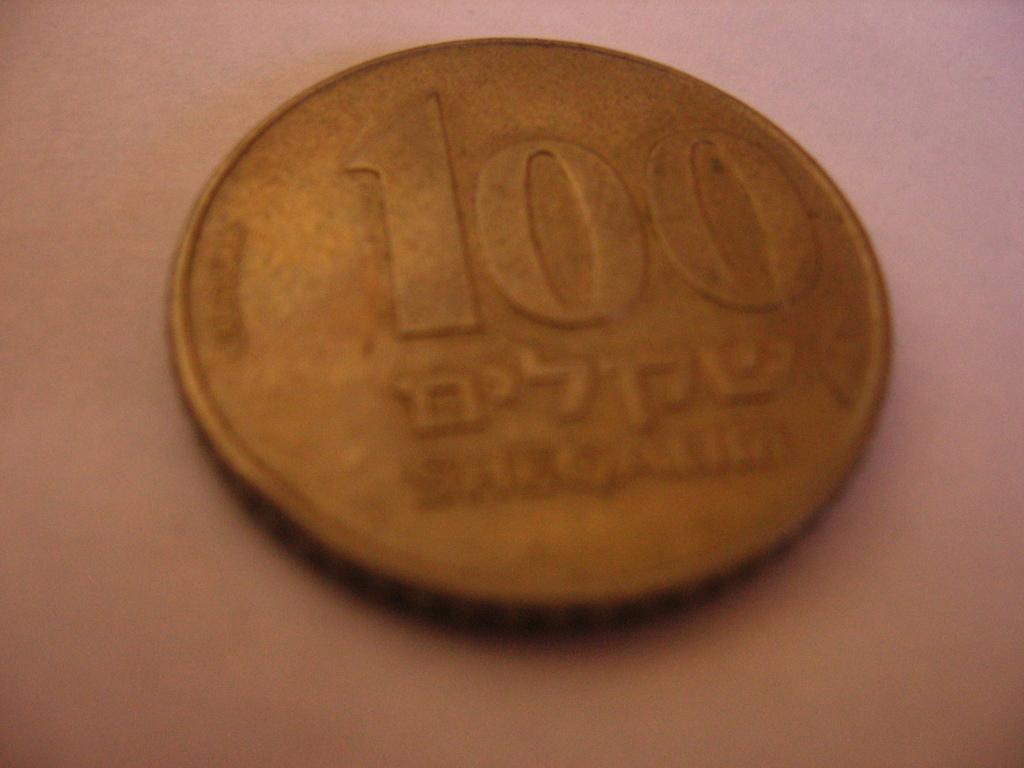In one or two sentences, can you explain what this image depicts? In this picture I can see the light brown color surface, on which there is a coin and I can see numbers and something written on it. 